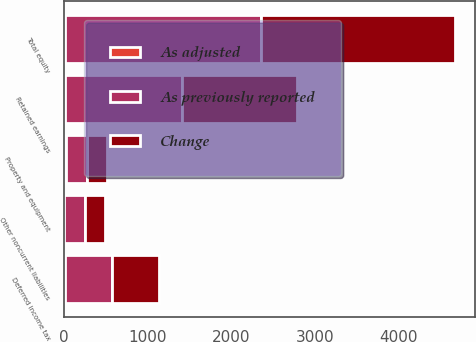<chart> <loc_0><loc_0><loc_500><loc_500><stacked_bar_chart><ecel><fcel>Property and equipment<fcel>Deferred income tax<fcel>Other noncurrent liabilities<fcel>Retained earnings<fcel>Total equity<nl><fcel>As previously reported<fcel>247.7<fcel>567.1<fcel>247.7<fcel>1394.6<fcel>2341.6<nl><fcel>Change<fcel>247.7<fcel>558.6<fcel>247.2<fcel>1378.8<fcel>2325.8<nl><fcel>As adjusted<fcel>24.8<fcel>8.5<fcel>0.5<fcel>15.8<fcel>15.8<nl></chart> 